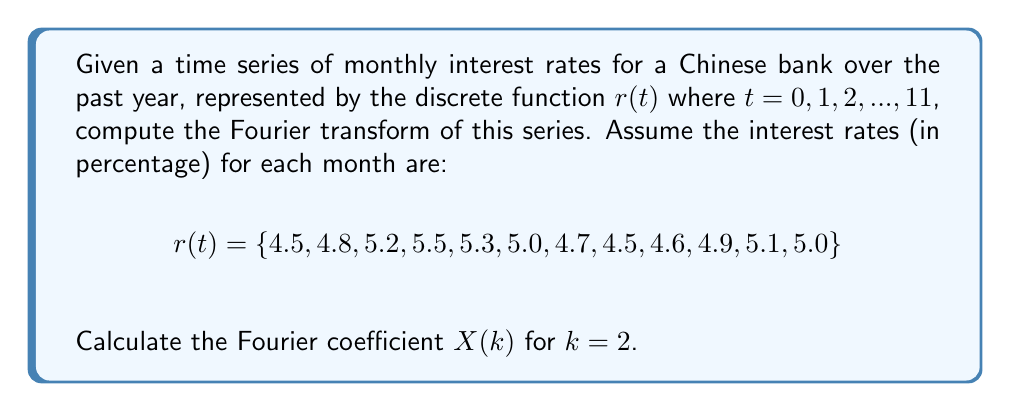Can you answer this question? To compute the Fourier transform of the discrete time series, we use the Discrete Fourier Transform (DFT) formula:

$$X(k) = \sum_{t=0}^{N-1} r(t) \cdot e^{-i2\pi kt/N}$$

Where:
- $N$ is the number of samples (12 in this case)
- $k$ is the frequency index (we need to calculate for $k = 2$)
- $t$ is the time index
- $r(t)$ is the interest rate at time $t$

Steps to calculate $X(2)$:

1) Expand the formula for $k = 2$:
   $$X(2) = \sum_{t=0}^{11} r(t) \cdot e^{-i2\pi 2t/12}$$

2) Simplify the exponent:
   $$X(2) = \sum_{t=0}^{11} r(t) \cdot e^{-i\pi t/3}$$

3) Calculate $e^{-i\pi t/3}$ for each $t$:
   $t = 0: e^0 = 1$
   $t = 1: e^{-i\pi/3} = 0.5 - i0.866$
   $t = 2: e^{-i2\pi/3} = -0.5 - i0.866$
   $t = 3: e^{-i\pi} = -1$
   $t = 4: e^{-i4\pi/3} = -0.5 + i0.866$
   $t = 5: e^{-i5\pi/3} = 0.5 + i0.866$
   $t = 6: e^{-i2\pi} = 1$
   ... (pattern repeats)

4) Multiply each $r(t)$ by its corresponding $e^{-i\pi t/3}$ and sum:

   $X(2) = 4.5 + (4.8)(0.5 - i0.866) + (5.2)(-0.5 - i0.866) + (5.5)(-1) + 
           (5.3)(-0.5 + i0.866) + (5.0)(0.5 + i0.866) + 4.7 + 
           (4.5)(0.5 - i0.866) + (4.6)(-0.5 - i0.866) + (4.9)(-1) + 
           (5.1)(-0.5 + i0.866) + (5.0)(0.5 + i0.866)$

5) Simplify and combine real and imaginary parts:
   $X(2) = (-0.85) + (-0.779i)$
Answer: $X(2) = -0.85 - 0.779i$ 